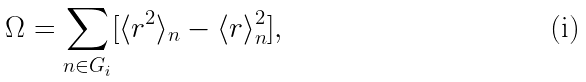<formula> <loc_0><loc_0><loc_500><loc_500>\Omega = \sum _ { n \in G _ { i } } [ \langle r ^ { 2 } \rangle _ { n } - \langle r \rangle _ { n } ^ { 2 } ] ,</formula> 